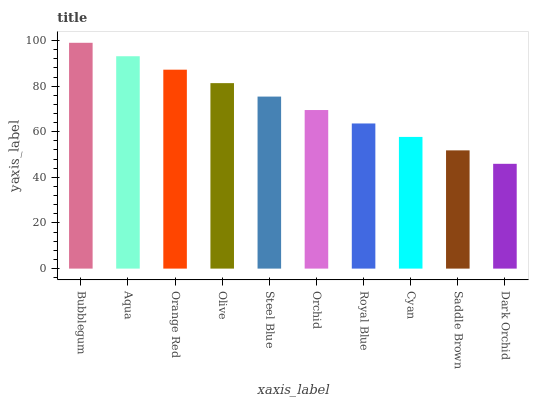Is Dark Orchid the minimum?
Answer yes or no. Yes. Is Bubblegum the maximum?
Answer yes or no. Yes. Is Aqua the minimum?
Answer yes or no. No. Is Aqua the maximum?
Answer yes or no. No. Is Bubblegum greater than Aqua?
Answer yes or no. Yes. Is Aqua less than Bubblegum?
Answer yes or no. Yes. Is Aqua greater than Bubblegum?
Answer yes or no. No. Is Bubblegum less than Aqua?
Answer yes or no. No. Is Steel Blue the high median?
Answer yes or no. Yes. Is Orchid the low median?
Answer yes or no. Yes. Is Royal Blue the high median?
Answer yes or no. No. Is Olive the low median?
Answer yes or no. No. 